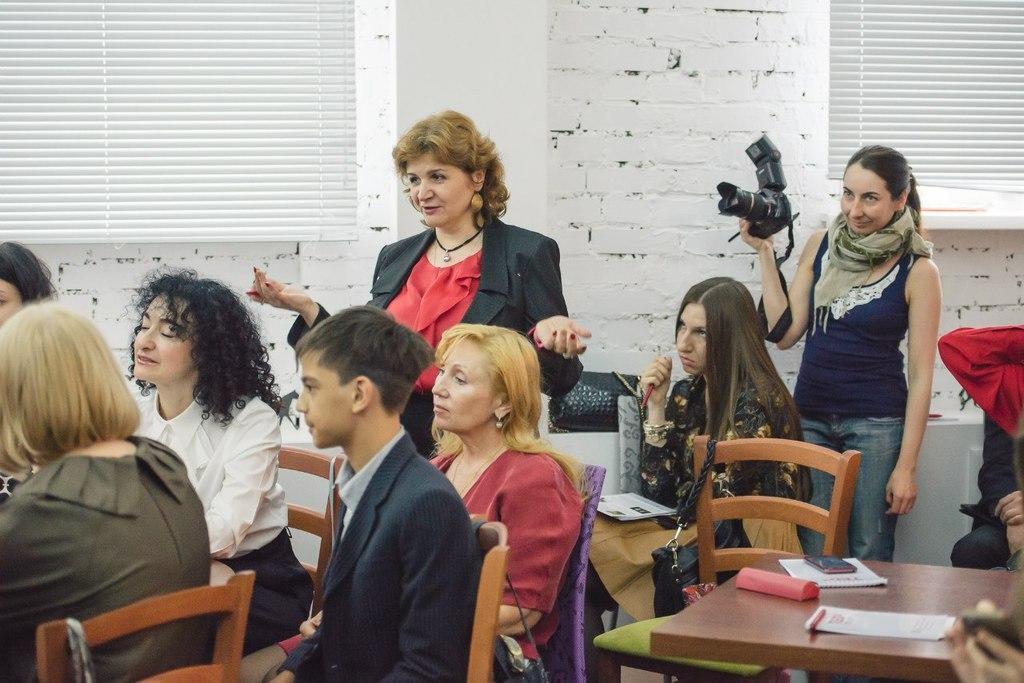In one or two sentences, can you explain what this image depicts? In this image I can see people where few are standing and rest all are sitting on chairs. I can see one of them is holding a camera. I can also see a table and on it I can see few papers and few other stuffs. In background I can see white colour wall and window blinds. 